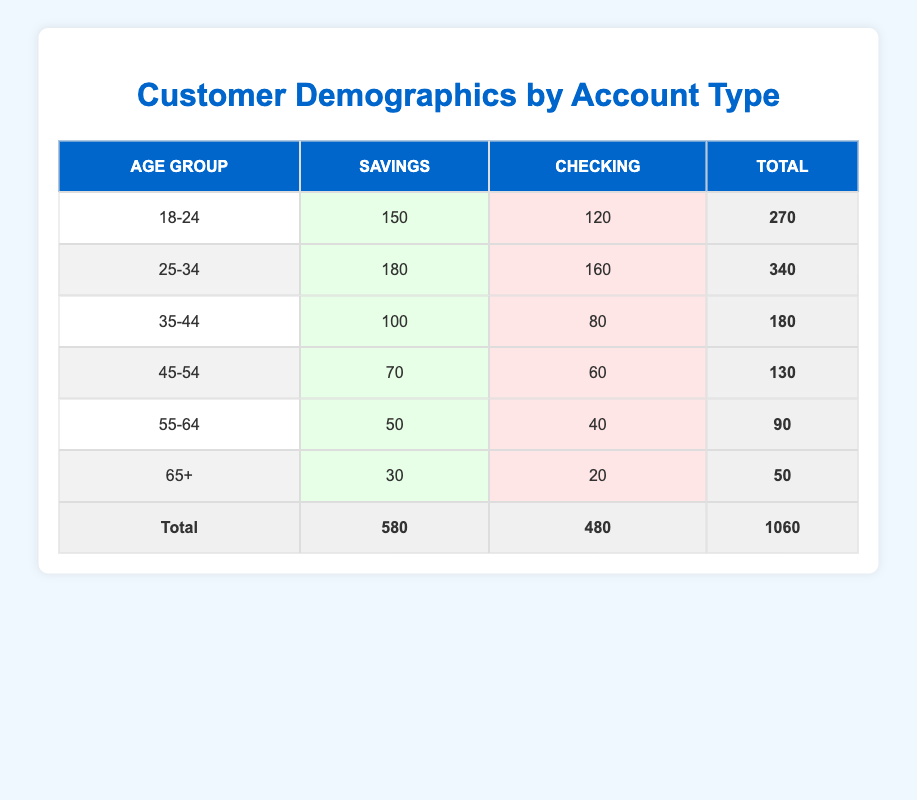What is the total number of customers in the 18-24 age group? The table shows that in the 18-24 age group, there are 150 customers with Savings accounts and 120 customers with Checking accounts. To find the total, we sum these values: 150 + 120 = 270.
Answer: 270 How many more Savings account holders are there in the 25-34 age group compared to the 35-44 age group? From the table, we see that there are 180 Savings account holders in the 25-34 age group and 100 in the 35-44 age group. To find the difference, we subtract: 180 - 100 = 80.
Answer: 80 What percent of the total customers are above the age of 54? The total number of customers is 1060. The number of customers above 54 (55-64 and 65+) is 50 + 30 + 40 + 20 = 140. To find the percentage, we calculate (140 / 1060) * 100 = approximately 13.21%.
Answer: 13.21 percent Are there more Checking account holders in the 45-54 age group than in the 35-44 age group? In the 45-54 age group, there are 60 Checking account holders, and in the 35-44 age group, there are 80. Since 60 is less than 80, the statement is false.
Answer: No What is the average number of Savings account holders across all age groups? To find the average, we sum all Savings account holders: 150 + 180 + 100 + 70 + 50 + 30 = 580. There are 6 age groups, so we divide the total by the number of groups: 580 / 6 = approximately 96.67.
Answer: 96.67 How many total Checking account holders are there under the age of 35? The age groups under 35 are 18-24 and 25-34. From the table, we find there are 120 Checking account holders in 18-24 and 160 in 25-34. Adding these gives us 120 + 160 = 280.
Answer: 280 What is the total number of Savings account holders across all age groups? The Savings account holders are 150 + 180 + 100 + 70 + 50 + 30 = 580. This is the total number of Savings account holders across all age groups in the table.
Answer: 580 How many total customers aged 65 or older are there? The table shows 30 Savings and 20 Checking account holders aged 65 or older. Therefore, the total is 30 + 20 = 50.
Answer: 50 